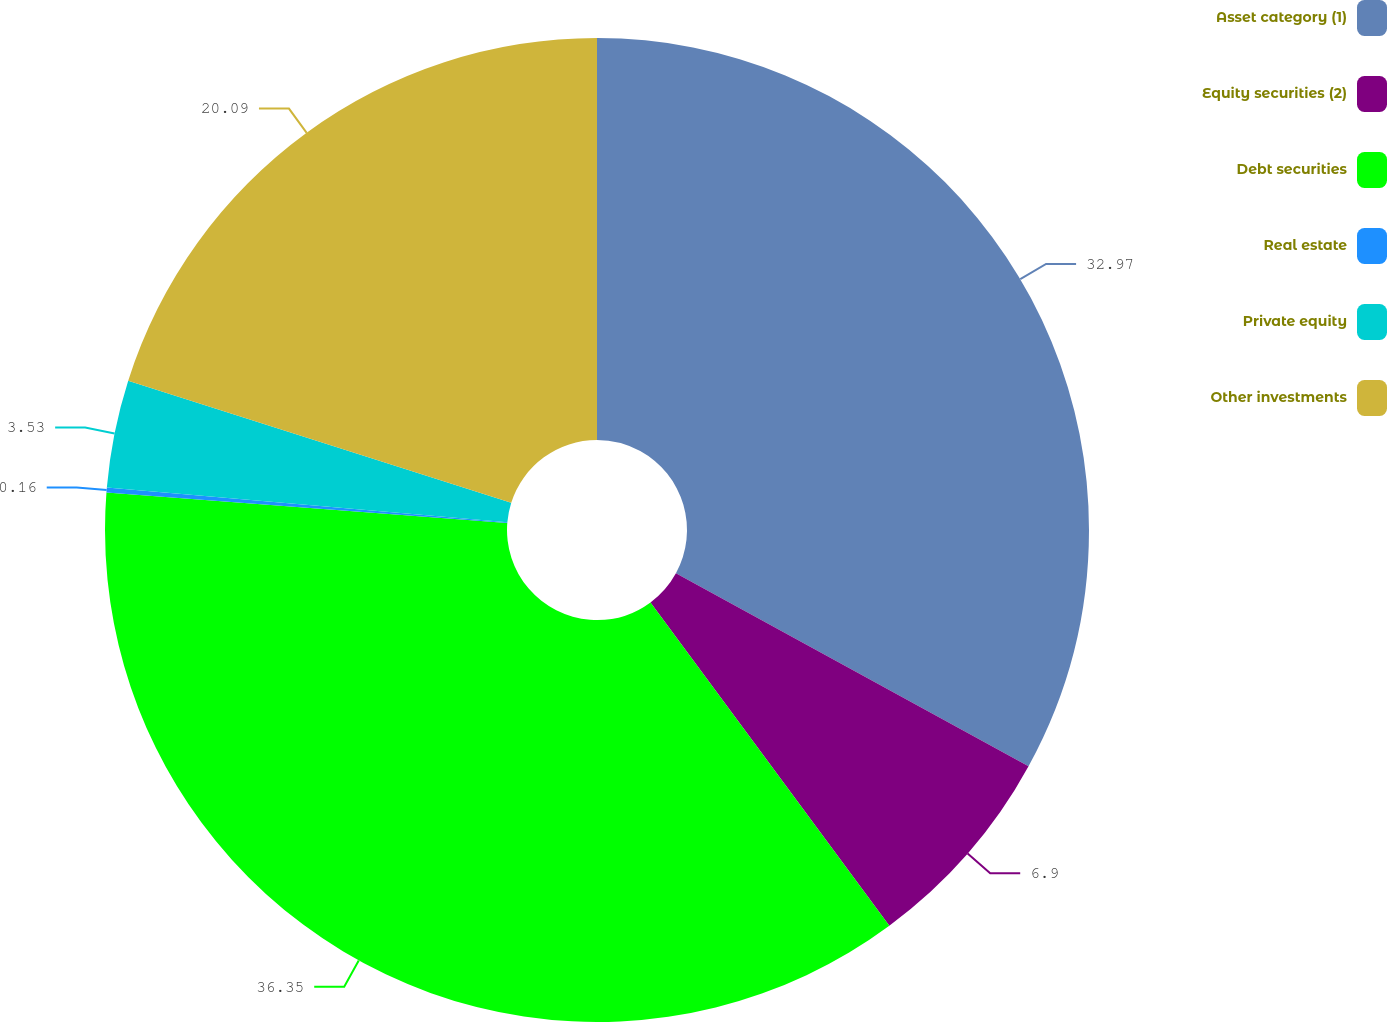Convert chart. <chart><loc_0><loc_0><loc_500><loc_500><pie_chart><fcel>Asset category (1)<fcel>Equity securities (2)<fcel>Debt securities<fcel>Real estate<fcel>Private equity<fcel>Other investments<nl><fcel>32.97%<fcel>6.9%<fcel>36.34%<fcel>0.16%<fcel>3.53%<fcel>20.09%<nl></chart> 